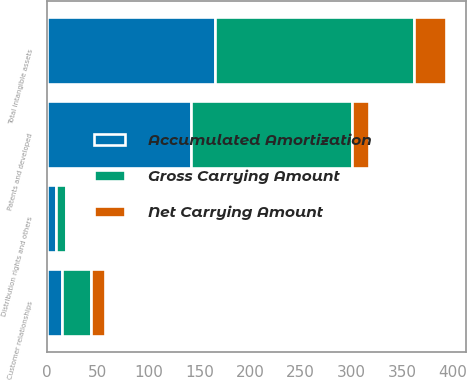Convert chart. <chart><loc_0><loc_0><loc_500><loc_500><stacked_bar_chart><ecel><fcel>Patents and developed<fcel>Distribution rights and others<fcel>Customer relationships<fcel>Total intangible assets<nl><fcel>Gross Carrying Amount<fcel>158.7<fcel>9.2<fcel>28.6<fcel>196.5<nl><fcel>Accumulated Amortization<fcel>141.6<fcel>9.1<fcel>14.3<fcel>165<nl><fcel>Net Carrying Amount<fcel>17.1<fcel>0.1<fcel>14.3<fcel>31.5<nl></chart> 